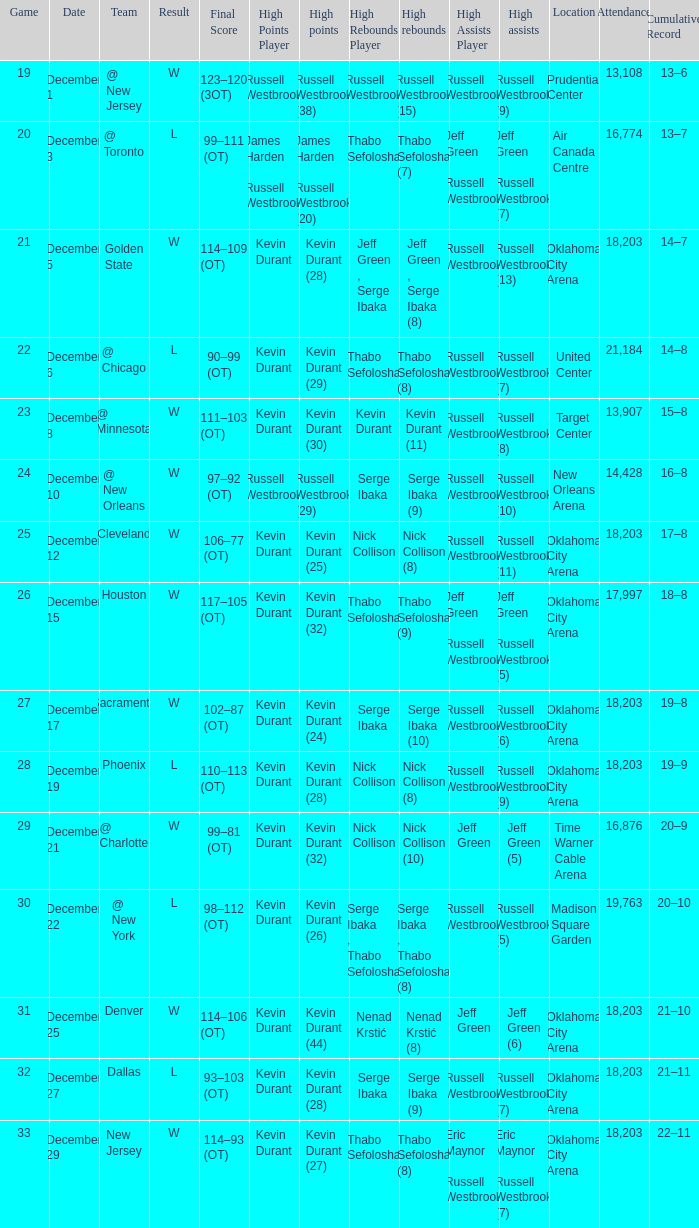Who had the high rebounds record on December 12? Nick Collison (8). 